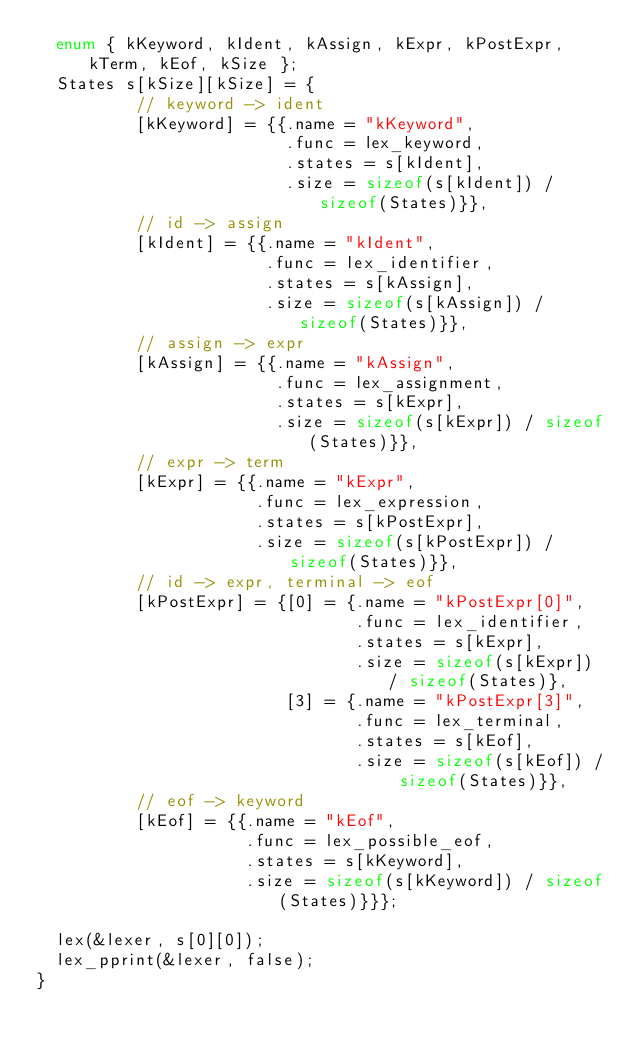Convert code to text. <code><loc_0><loc_0><loc_500><loc_500><_C_>  enum { kKeyword, kIdent, kAssign, kExpr, kPostExpr, kTerm, kEof, kSize };
  States s[kSize][kSize] = {
          // keyword -> ident
          [kKeyword] = {{.name = "kKeyword",
                         .func = lex_keyword,
                         .states = s[kIdent],
                         .size = sizeof(s[kIdent]) / sizeof(States)}},
          // id -> assign
          [kIdent] = {{.name = "kIdent",
                       .func = lex_identifier,
                       .states = s[kAssign],
                       .size = sizeof(s[kAssign]) / sizeof(States)}},
          // assign -> expr
          [kAssign] = {{.name = "kAssign",
                        .func = lex_assignment,
                        .states = s[kExpr],
                        .size = sizeof(s[kExpr]) / sizeof(States)}},
          // expr -> term
          [kExpr] = {{.name = "kExpr",
                      .func = lex_expression,
                      .states = s[kPostExpr],
                      .size = sizeof(s[kPostExpr]) / sizeof(States)}},
          // id -> expr, terminal -> eof
          [kPostExpr] = {[0] = {.name = "kPostExpr[0]",
                                .func = lex_identifier,
                                .states = s[kExpr],
                                .size = sizeof(s[kExpr]) / sizeof(States)},
                         [3] = {.name = "kPostExpr[3]",
                                .func = lex_terminal,
                                .states = s[kEof],
                                .size = sizeof(s[kEof]) / sizeof(States)}},
          // eof -> keyword
          [kEof] = {{.name = "kEof",
                     .func = lex_possible_eof,
                     .states = s[kKeyword],
                     .size = sizeof(s[kKeyword]) / sizeof(States)}}};

  lex(&lexer, s[0][0]);
  lex_pprint(&lexer, false);
}
</code> 